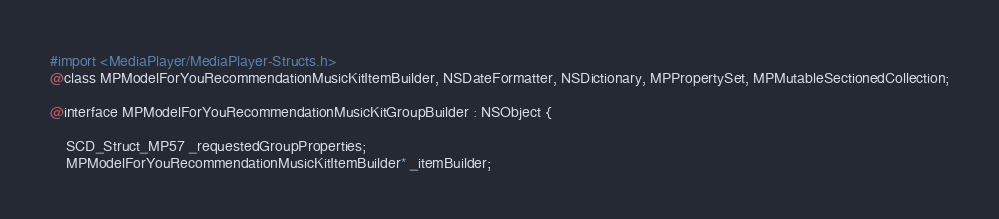<code> <loc_0><loc_0><loc_500><loc_500><_C_>

#import <MediaPlayer/MediaPlayer-Structs.h>
@class MPModelForYouRecommendationMusicKitItemBuilder, NSDateFormatter, NSDictionary, MPPropertySet, MPMutableSectionedCollection;

@interface MPModelForYouRecommendationMusicKitGroupBuilder : NSObject {

	SCD_Struct_MP57 _requestedGroupProperties;
	MPModelForYouRecommendationMusicKitItemBuilder* _itemBuilder;</code> 